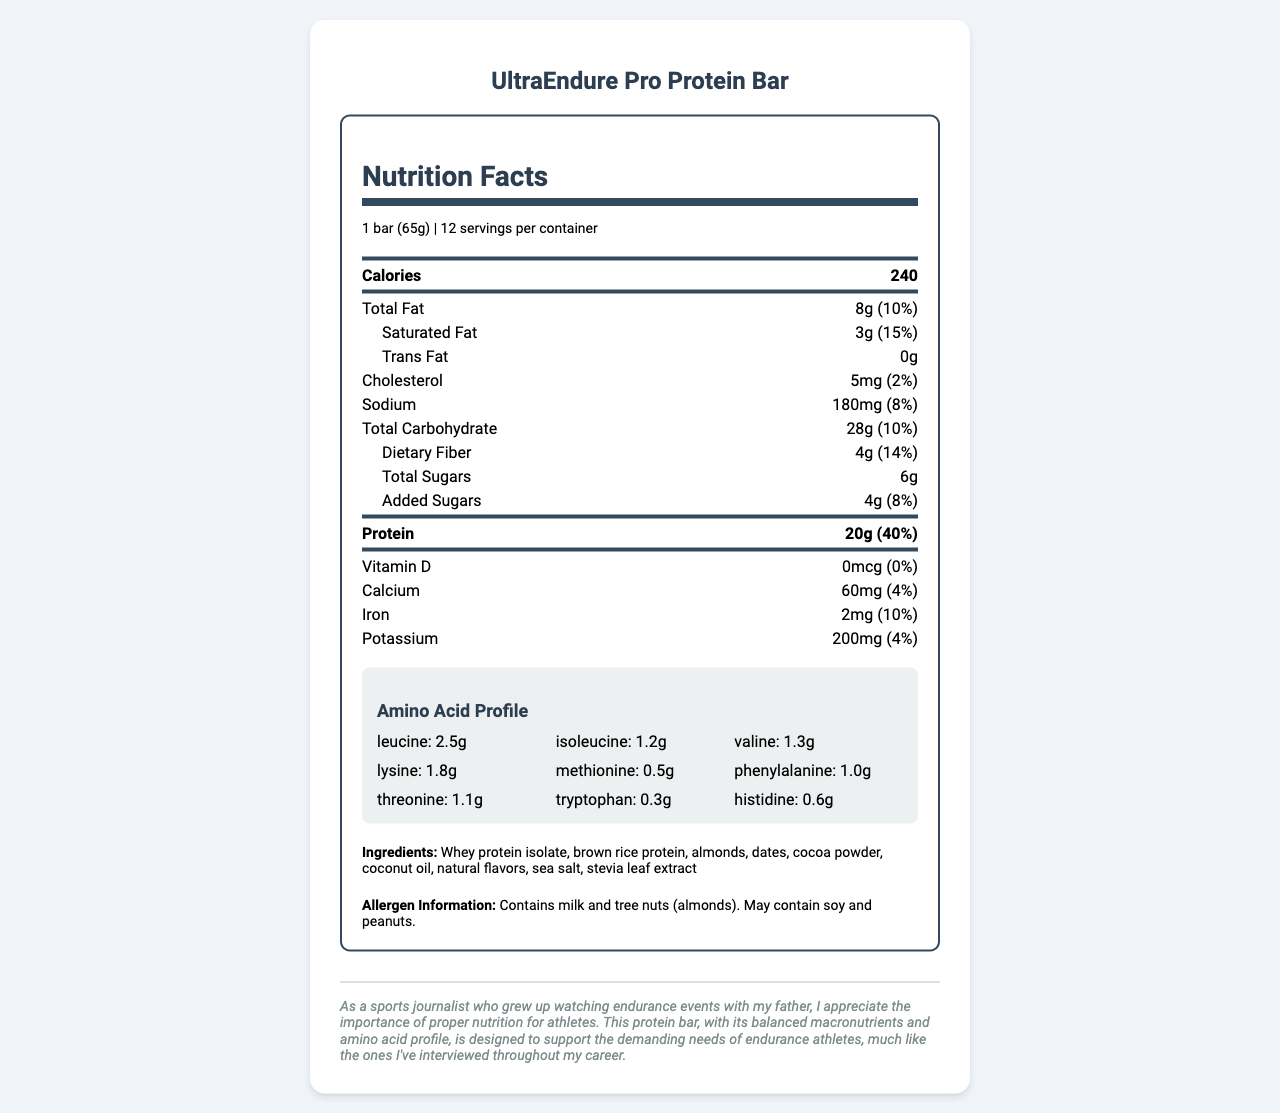what is the serving size of the UltraEndure Pro Protein Bar? The document lists the serving size clearly at the beginning as "1 bar (65g)".
Answer: 1 bar (65g) how much protein does one bar contain? The protein content per serving is prominently listed as "20g".
Answer: 20g what are the total calories per serving? The calorie content per serving is listed right at the top of the Nutrition Facts section as "240".
Answer: 240 what is the daily value percentage of dietary fiber? The daily value percentage for dietary fiber is clearly indicated as "14%" next to the amount of dietary fiber.
Answer: 14% name two ingredients in the UltraEndure Pro Protein Bar. The ingredients list contains "Whey protein isolate, brown rice protein, almonds, dates, cocoa powder, coconut oil, natural flavors, sea salt, stevia leaf extract". Whey protein isolate and almonds are two of these ingredients.
Answer: Whey protein isolate, almonds which amino acid is present in the highest amount in the UltraEndure Pro Protein Bar? A. Leucine B. Isoleucine C. Lysine D. Valine The document shows the amino acid profile with Leucine amount being 2.5g, which is the highest among the listed amino acids.
Answer: A. Leucine what is the daily value percentage for sodium? A. 2% B. 4% C. 8% D. 10% The document states the daily value percentage for sodium as "8%".
Answer: C. 8% does the UltraEndure Pro Protein Bar contain any trans fat? The trans fat is listed as "0g", implying there is no trans fat in the bar.
Answer: No does this protein bar contain soy? The allergen information notes that the bar "May contain soy and peanuts."
Answer: May contain summarize the key features of the UltraEndure Pro Protein Bar. This summary includes the protein content, calorie count, main ingredients, macronutrient balance, amino acid profile, and allergen information.
Answer: The UltraEndure Pro Protein Bar is designed for endurance athletes and contains 20g of protein per serving, derived from ingredients such as whey protein isolate and brown rice protein. It offers a balanced profile with 240 calories, 8g of fat, 28g of carbohydrates, and an array of essential amino acids. Additionally, it provides dietary fiber and is gluten-free. It may contain allergens like milk, tree nuts, soy, and peanuts. what is the total fat content in the UltraEndure Pro Protein Bar? The total fat content is listed as "8g" next to its percentage daily value.
Answer: 8g how many servings per container are there? The document notes there are "12" servings per container.
Answer: 12 what is the combined weight of isoleucine and valine in the amino acid profile? The weights of isoleucine and valine are 1.2g and 1.3g respectively. Adding them together gives a total of 2.5g.
Answer: 2.5g what is the main benefit for endurance athletes consuming this bar? The bar contains 20g of protein and a comprehensive amino acid profile, which are critical for muscle repair and recovery for endurance athletes.
Answer: High protein content and well-balanced amino acid profile how much potassium is in one bar? The amount of potassium per protein bar is listed as "200mg".
Answer: 200mg how is the protein content derived in this bar? A. Soy protein B. Whey protein isolate C. Pea protein D. Hemp protein The ingredient list specifies that the protein is derived from "whey protein isolate" and "brown rice protein".
Answer: B. Whey protein isolate who can benefit most from consuming the UltraEndure Pro Protein Bar? Based on the protein and amino acid content as well as the marketing note, this bar is specifically designed to meet the demands of endurance athletes.
Answer: Endurance athletes what is the added sugars content? A. 2g B. 4g C. 6g D. 8g The document shows that the added sugars content is "4g".
Answer: B. 4g why does this bar have zero daily value percentage for Vitamin D? The document indicates there is "0mcg" of Vitamin D, leading to a daily value percentage of "0%".
Answer: It contains 0mcg of Vitamin D is there enough information to determine the production cost of one bar? The document provides extensive nutritional information but does not contain any details related to production costs.
Answer: Not enough information 